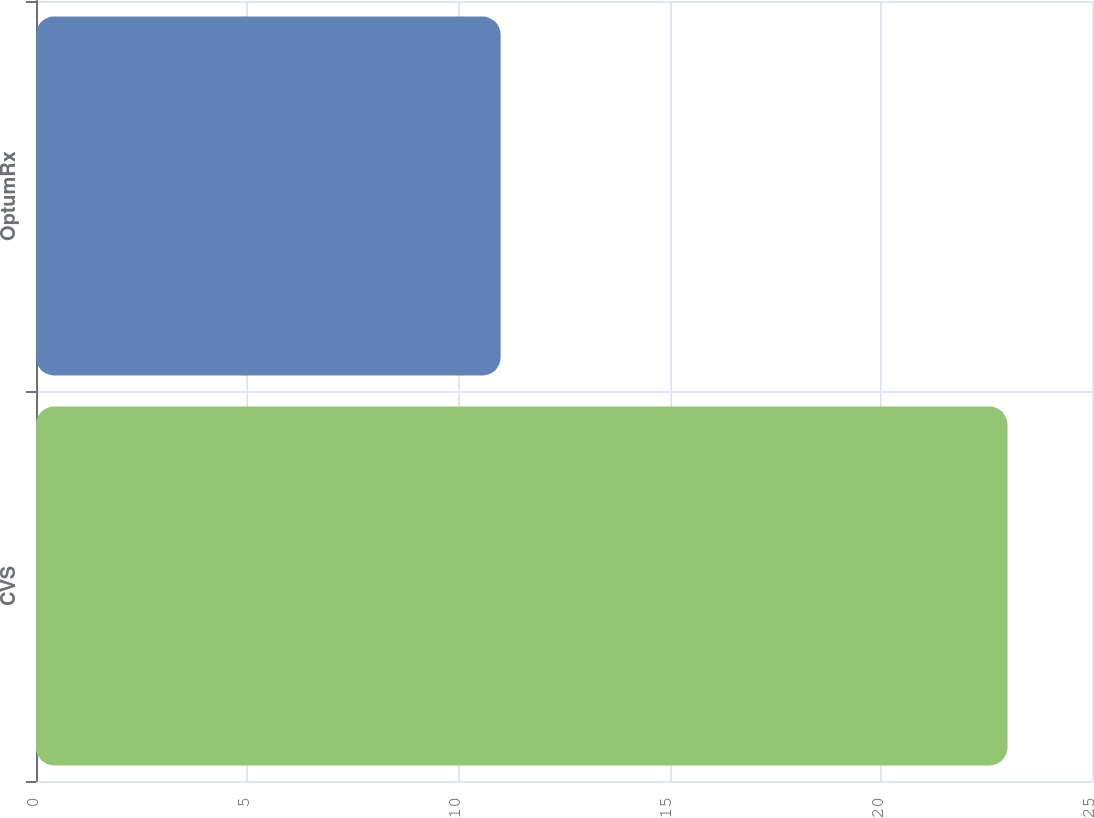<chart> <loc_0><loc_0><loc_500><loc_500><bar_chart><fcel>CVS<fcel>OptumRx<nl><fcel>23<fcel>11<nl></chart> 